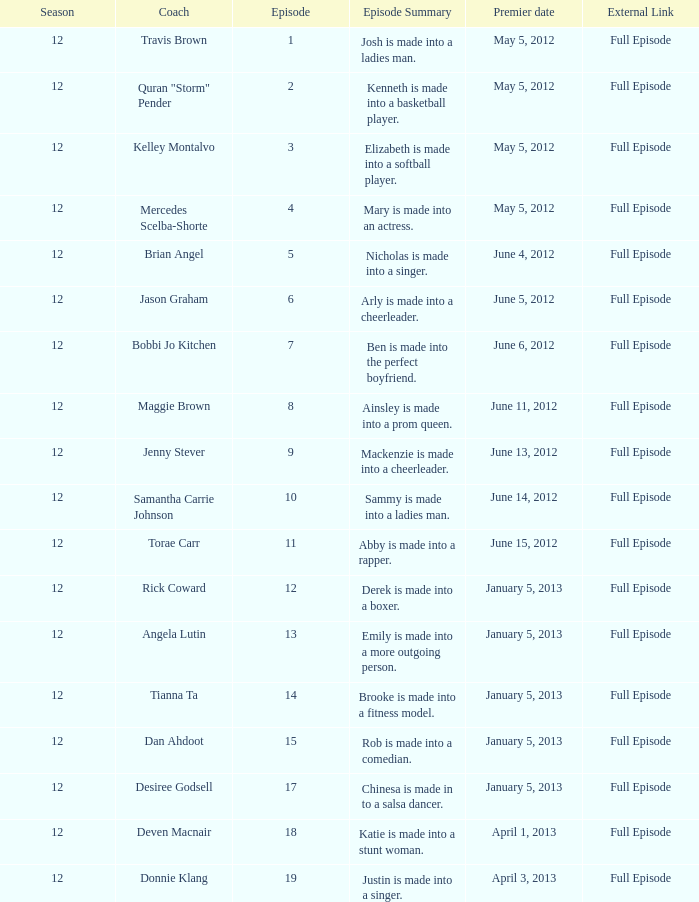Name the coach for  emily is made into a more outgoing person. Angela Lutin. 